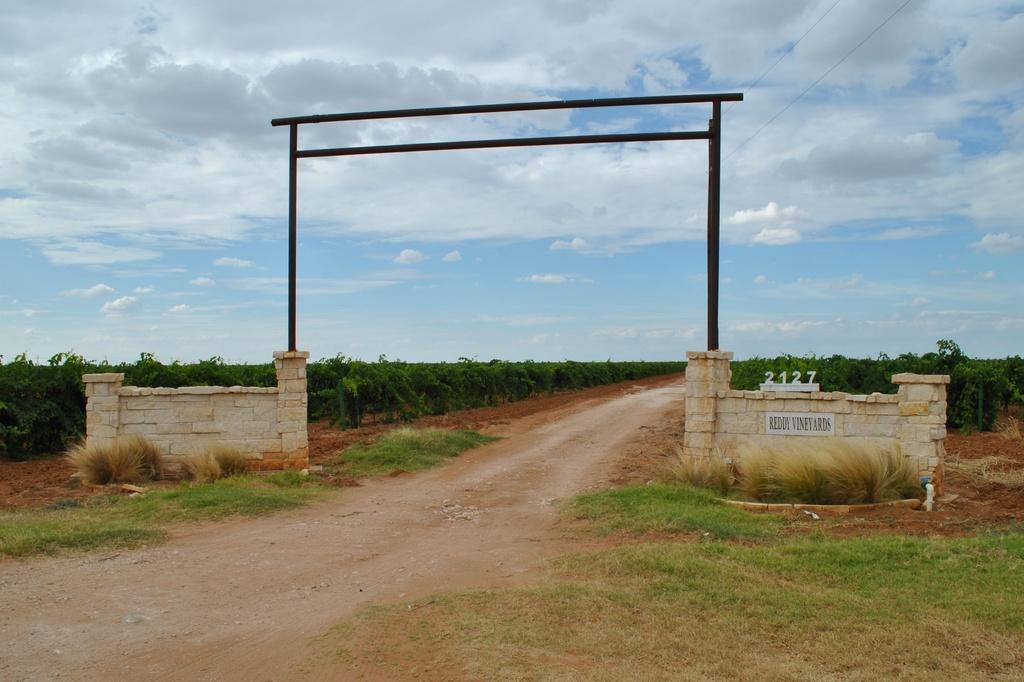What architectural feature can be seen on the wall in the image? There is an arch on a wall in the image. What is in the middle of the image? There is a path in the middle of the image. What type of vegetation is present on either side of the path? There are plants on either side of the path. Where are the plants located? The plants are on the land. What is visible in the background of the image? The sky is visible in the image, and clouds are present in the sky. How many cattle can be seen grazing in the territory depicted in the image? There are no cattle present in the image; it features an arch, a path, plants, and a sky with clouds. 